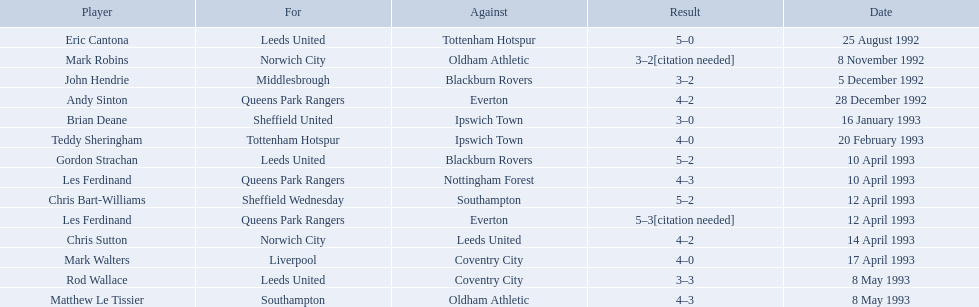Who are all the players? Eric Cantona, Mark Robins, John Hendrie, Andy Sinton, Brian Deane, Teddy Sheringham, Gordon Strachan, Les Ferdinand, Chris Bart-Williams, Les Ferdinand, Chris Sutton, Mark Walters, Rod Wallace, Matthew Le Tissier. What were their results? 5–0, 3–2[citation needed], 3–2, 4–2, 3–0, 4–0, 5–2, 4–3, 5–2, 5–3[citation needed], 4–2, 4–0, 3–3, 4–3. Which player tied with mark robins? John Hendrie. What are the results? 5–0, 3–2[citation needed], 3–2, 4–2, 3–0, 4–0, 5–2, 4–3, 5–2, 5–3[citation needed], 4–2, 4–0, 3–3, 4–3. What result did mark robins have? 3–2[citation needed]. What other player had that result? John Hendrie. Who are all the participants? Eric Cantona, Mark Robins, John Hendrie, Andy Sinton, Brian Deane, Teddy Sheringham, Gordon Strachan, Les Ferdinand, Chris Bart-Williams, Les Ferdinand, Chris Sutton, Mark Walters, Rod Wallace, Matthew Le Tissier. What were their outcomes? 5–0, 3–2[citation needed], 3–2, 4–2, 3–0, 4–0, 5–2, 4–3, 5–2, 5–3[citation needed], 4–2, 4–0, 3–3, 4–3. Which competitor had the same score as mark robins? John Hendrie. Can you list all the players? Eric Cantona, Mark Robins, John Hendrie, Andy Sinton, Brian Deane, Teddy Sheringham, Gordon Strachan, Les Ferdinand, Chris Bart-Williams, Les Ferdinand, Chris Sutton, Mark Walters, Rod Wallace, Matthew Le Tissier. What were the outcomes for each? 5–0, 3–2[citation needed], 3–2, 4–2, 3–0, 4–0, 5–2, 4–3, 5–2, 5–3[citation needed], 4–2, 4–0, 3–3, 4–3. Who had a tie with mark robins? John Hendrie. Who were all the players involved? Eric Cantona, Mark Robins, John Hendrie, Andy Sinton, Brian Deane, Teddy Sheringham, Gordon Strachan, Les Ferdinand, Chris Bart-Williams, Les Ferdinand, Chris Sutton, Mark Walters, Rod Wallace, Matthew Le Tissier. What were their individual results? 5–0, 3–2[citation needed], 3–2, 4–2, 3–0, 4–0, 5–2, 4–3, 5–2, 5–3[citation needed], 4–2, 4–0, 3–3, 4–3. Which player had a draw with mark robins? John Hendrie. What are the outcomes? 5–0, 3–2[citation needed], 3–2, 4–2, 3–0, 4–0, 5–2, 4–3, 5–2, 5–3[citation needed], 4–2, 4–0, 3–3, 4–3. What was mark robins' outcome? 3–2[citation needed]. Which other player experienced that outcome? John Hendrie. What were the consequences? 5–0, 3–2[citation needed], 3–2, 4–2, 3–0, 4–0, 5–2, 4–3, 5–2, 5–3[citation needed], 4–2, 4–0, 3–3, 4–3. What consequence did mark robins encounter? 3–2[citation needed]. Parse the table in full. {'header': ['Player', 'For', 'Against', 'Result', 'Date'], 'rows': [['Eric Cantona', 'Leeds United', 'Tottenham Hotspur', '5–0', '25 August 1992'], ['Mark Robins', 'Norwich City', 'Oldham Athletic', '3–2[citation needed]', '8 November 1992'], ['John Hendrie', 'Middlesbrough', 'Blackburn Rovers', '3–2', '5 December 1992'], ['Andy Sinton', 'Queens Park Rangers', 'Everton', '4–2', '28 December 1992'], ['Brian Deane', 'Sheffield United', 'Ipswich Town', '3–0', '16 January 1993'], ['Teddy Sheringham', 'Tottenham Hotspur', 'Ipswich Town', '4–0', '20 February 1993'], ['Gordon Strachan', 'Leeds United', 'Blackburn Rovers', '5–2', '10 April 1993'], ['Les Ferdinand', 'Queens Park Rangers', 'Nottingham Forest', '4–3', '10 April 1993'], ['Chris Bart-Williams', 'Sheffield Wednesday', 'Southampton', '5–2', '12 April 1993'], ['Les Ferdinand', 'Queens Park Rangers', 'Everton', '5–3[citation needed]', '12 April 1993'], ['Chris Sutton', 'Norwich City', 'Leeds United', '4–2', '14 April 1993'], ['Mark Walters', 'Liverpool', 'Coventry City', '4–0', '17 April 1993'], ['Rod Wallace', 'Leeds United', 'Coventry City', '3–3', '8 May 1993'], ['Matthew Le Tissier', 'Southampton', 'Oldham Athletic', '4–3', '8 May 1993']]} What other athlete shared that consequence? John Hendrie. What were the findings? 5–0, 3–2[citation needed], 3–2, 4–2, 3–0, 4–0, 5–2, 4–3, 5–2, 5–3[citation needed], 4–2, 4–0, 3–3, 4–3. What finding did mark robins obtain? 3–2[citation needed]. Which additional player had that same finding? John Hendrie. Who were the participants in the 1992-93 fa premier league season? Eric Cantona, Mark Robins, John Hendrie, Andy Sinton, Brian Deane, Teddy Sheringham, Gordon Strachan, Les Ferdinand, Chris Bart-Williams, Les Ferdinand, Chris Sutton, Mark Walters, Rod Wallace, Matthew Le Tissier. What was mark robins' performance? 3–2[citation needed]. Is there any player with a similar performance? John Hendrie. 